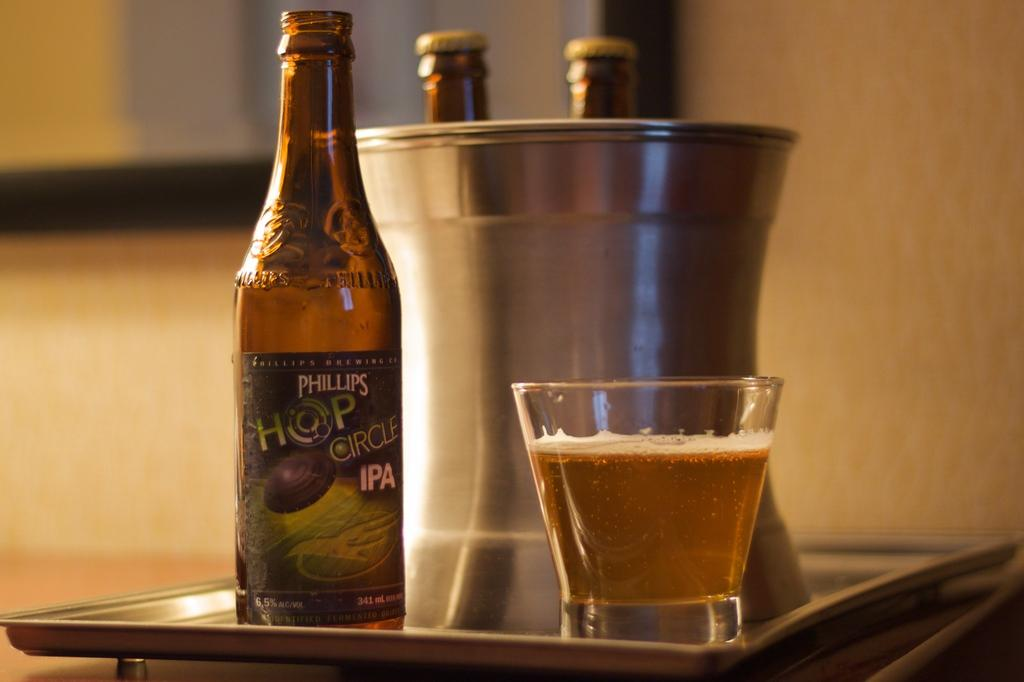<image>
Summarize the visual content of the image. a beer bottle with a label that says 'phillips shop circle ipa' 